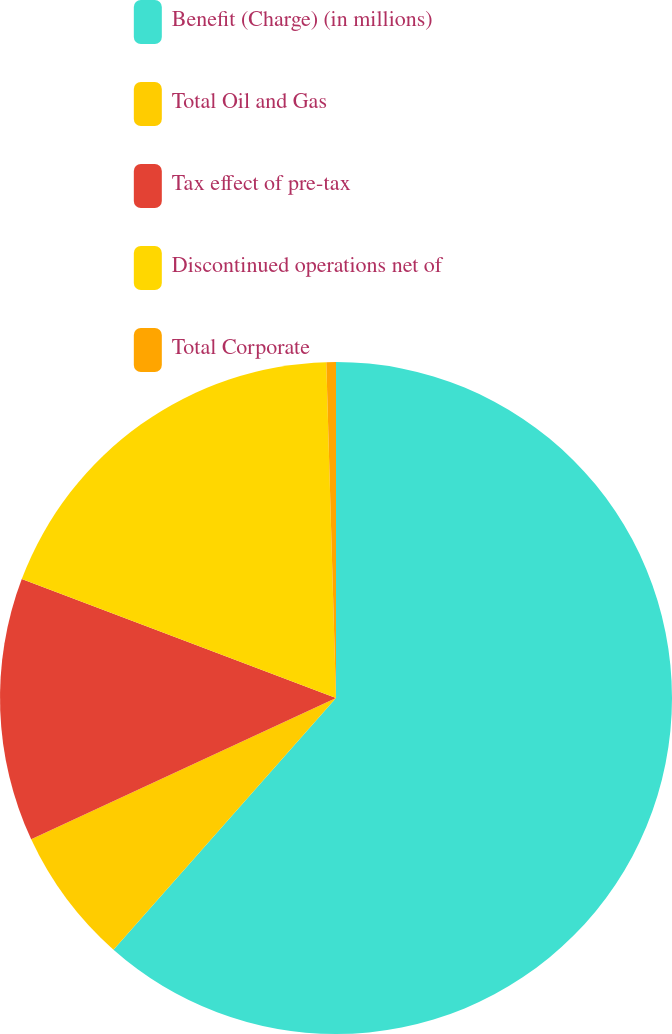<chart> <loc_0><loc_0><loc_500><loc_500><pie_chart><fcel>Benefit (Charge) (in millions)<fcel>Total Oil and Gas<fcel>Tax effect of pre-tax<fcel>Discontinued operations net of<fcel>Total Corporate<nl><fcel>61.52%<fcel>6.57%<fcel>12.67%<fcel>18.78%<fcel>0.46%<nl></chart> 